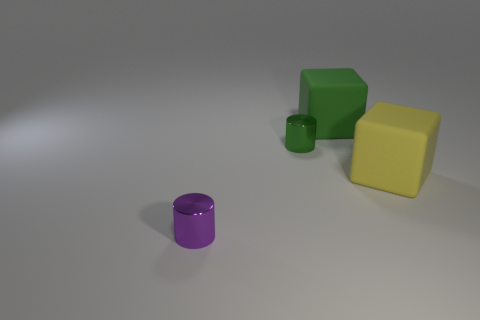Add 2 large yellow matte things. How many objects exist? 6 Subtract 2 cylinders. How many cylinders are left? 0 Add 2 green metallic cylinders. How many green metallic cylinders exist? 3 Subtract 0 yellow cylinders. How many objects are left? 4 Subtract all cyan cylinders. Subtract all red spheres. How many cylinders are left? 2 Subtract all yellow cylinders. How many yellow blocks are left? 1 Subtract all metal cylinders. Subtract all gray metallic spheres. How many objects are left? 2 Add 4 purple things. How many purple things are left? 5 